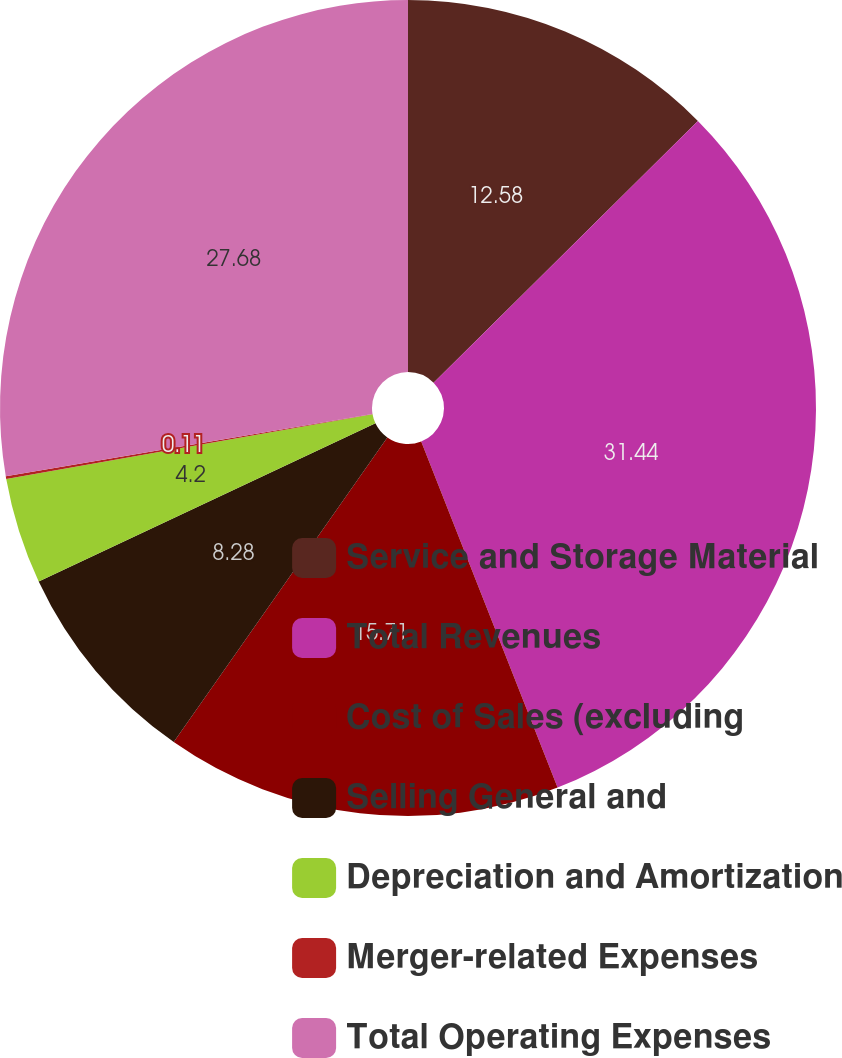Convert chart to OTSL. <chart><loc_0><loc_0><loc_500><loc_500><pie_chart><fcel>Service and Storage Material<fcel>Total Revenues<fcel>Cost of Sales (excluding<fcel>Selling General and<fcel>Depreciation and Amortization<fcel>Merger-related Expenses<fcel>Total Operating Expenses<nl><fcel>12.58%<fcel>31.45%<fcel>15.71%<fcel>8.28%<fcel>4.2%<fcel>0.11%<fcel>27.68%<nl></chart> 